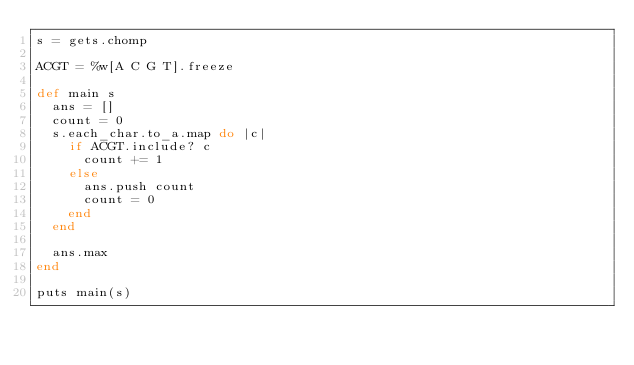<code> <loc_0><loc_0><loc_500><loc_500><_Ruby_>s = gets.chomp

ACGT = %w[A C G T].freeze

def main s
  ans = []
  count = 0
  s.each_char.to_a.map do |c|
    if ACGT.include? c
      count += 1
    else
      ans.push count
      count = 0
    end
  end

  ans.max
end

puts main(s)</code> 